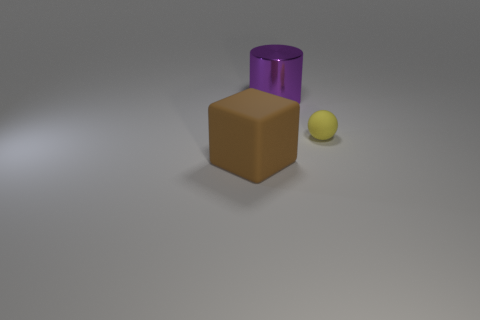Do the big thing that is in front of the purple metallic cylinder and the large purple metal object have the same shape?
Give a very brief answer. No. Are there any brown spheres made of the same material as the small thing?
Keep it short and to the point. No. There is a big object that is left of the thing that is behind the small ball; what is it made of?
Offer a terse response. Rubber. There is a matte thing that is to the left of the small yellow rubber sphere; how big is it?
Your answer should be compact. Large. There is a rubber sphere; does it have the same color as the large thing in front of the large purple cylinder?
Provide a short and direct response. No. Are there any objects that have the same color as the small rubber ball?
Ensure brevity in your answer.  No. Do the big brown object and the big purple object on the left side of the small yellow thing have the same material?
Provide a short and direct response. No. What number of large things are yellow objects or red metal cubes?
Offer a terse response. 0. Are there fewer yellow things than big metallic spheres?
Offer a very short reply. No. Do the rubber thing on the right side of the large brown cube and the matte object that is to the left of the large metallic cylinder have the same size?
Make the answer very short. No. 